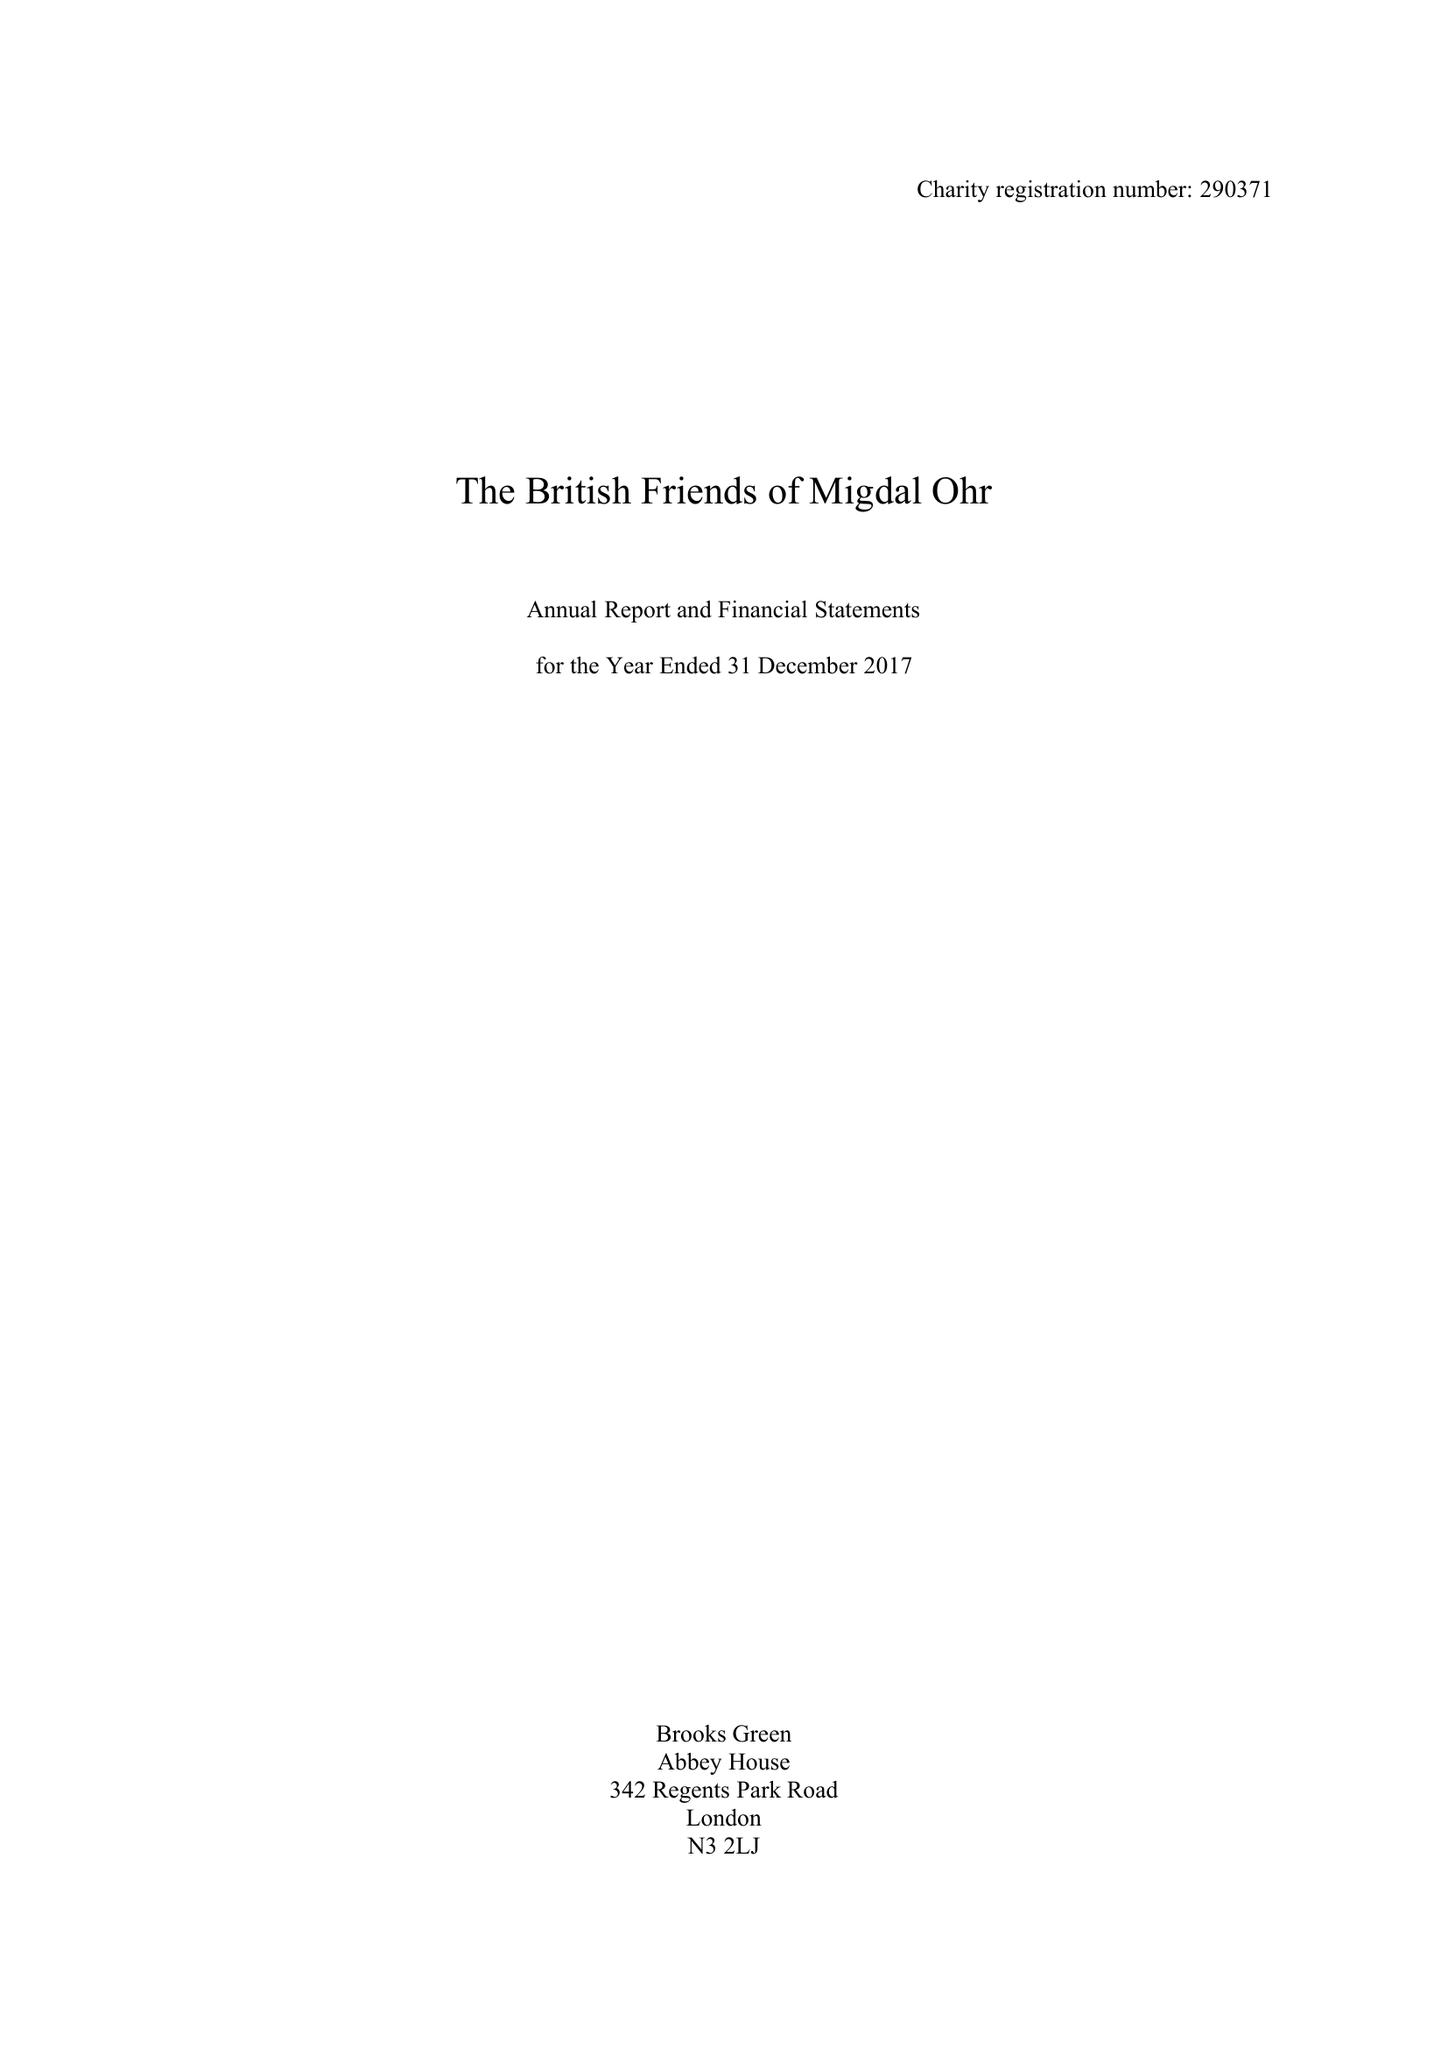What is the value for the charity_name?
Answer the question using a single word or phrase. The British Friends Of Migdal Ohr 